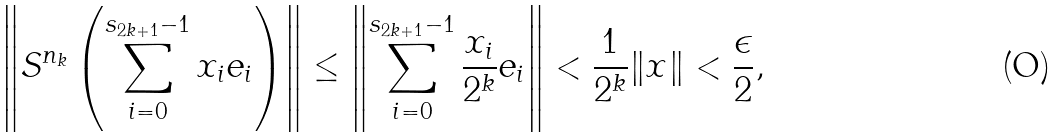<formula> <loc_0><loc_0><loc_500><loc_500>\left \| S ^ { n _ { k } } \left ( \sum _ { i = 0 } ^ { s _ { 2 k + 1 } - 1 } x _ { i } e _ { i } \right ) \right \| \leq \left \| \sum _ { i = 0 } ^ { s _ { 2 k + 1 } - 1 } \frac { x _ { i } } { 2 ^ { k } } e _ { i } \right \| < \frac { 1 } { 2 ^ { k } } \| x \| < \frac { \epsilon } { 2 } ,</formula> 